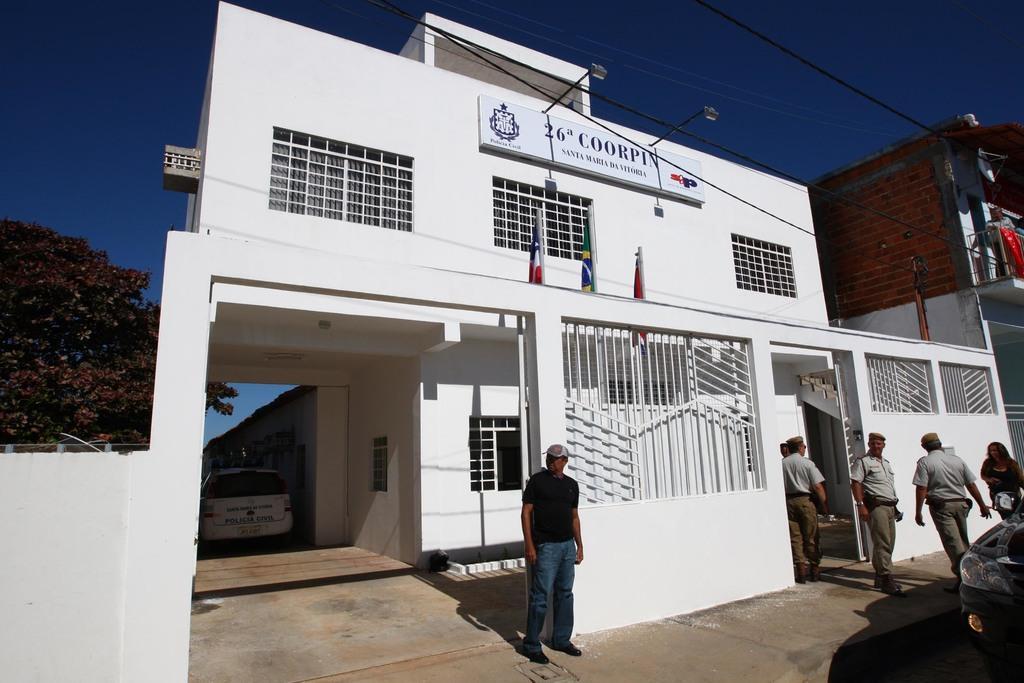Please provide a concise description of this image. This picture describes about group of people, few are standing and few are walking, beside to them we can see a car, in the background we can find few buildings, hoarding and lights, and also we can see a tree. 